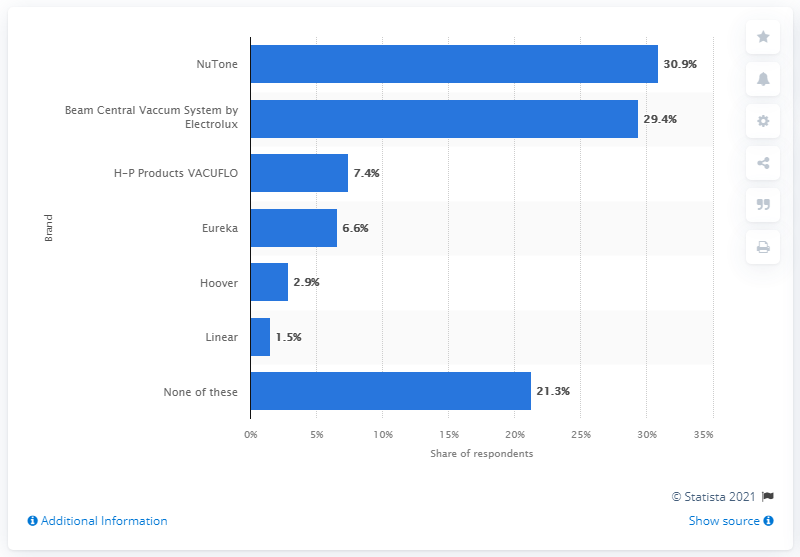Outline some significant characteristics in this image. A significant percentage of respondents, 30.9%, reported using NuTone brand central vacuums the most. 